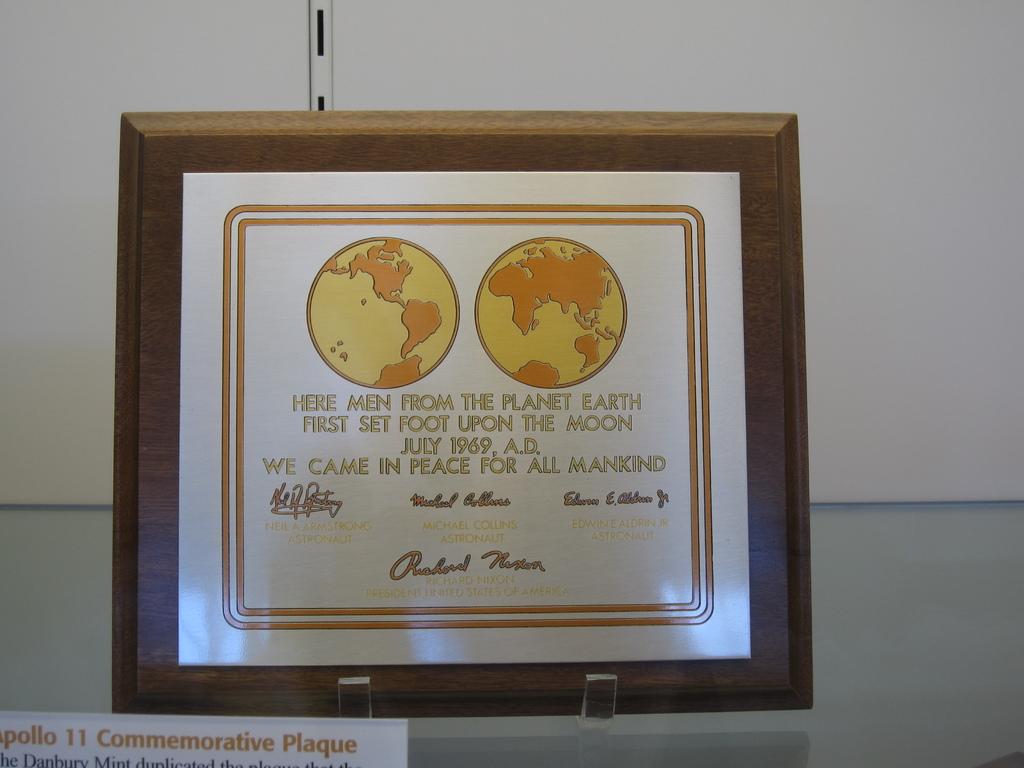What's the year printed on this?
Provide a short and direct response. 1969. 